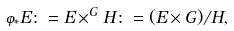Convert formula to latex. <formula><loc_0><loc_0><loc_500><loc_500>\varphi _ { * } E \colon = E \times ^ { G } H \colon = ( E \times G ) / H ,</formula> 